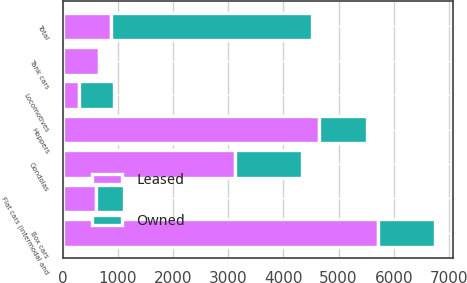Convert chart to OTSL. <chart><loc_0><loc_0><loc_500><loc_500><stacked_bar_chart><ecel><fcel>Locomotives<fcel>Box cars<fcel>Hoppers<fcel>Gondolas<fcel>Tank cars<fcel>Flat cars (intermodal and<fcel>Total<nl><fcel>Leased<fcel>295<fcel>5714<fcel>4644<fcel>3114<fcel>661<fcel>605<fcel>872<nl><fcel>Owned<fcel>628<fcel>1031<fcel>872<fcel>1229<fcel>15<fcel>501<fcel>3648<nl></chart> 